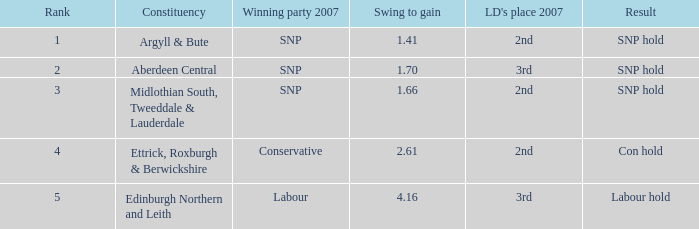16? None. 